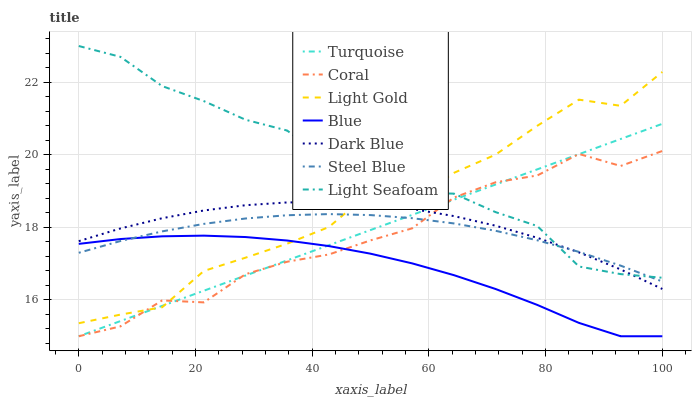Does Blue have the minimum area under the curve?
Answer yes or no. Yes. Does Light Seafoam have the maximum area under the curve?
Answer yes or no. Yes. Does Turquoise have the minimum area under the curve?
Answer yes or no. No. Does Turquoise have the maximum area under the curve?
Answer yes or no. No. Is Turquoise the smoothest?
Answer yes or no. Yes. Is Light Seafoam the roughest?
Answer yes or no. Yes. Is Coral the smoothest?
Answer yes or no. No. Is Coral the roughest?
Answer yes or no. No. Does Blue have the lowest value?
Answer yes or no. Yes. Does Steel Blue have the lowest value?
Answer yes or no. No. Does Light Seafoam have the highest value?
Answer yes or no. Yes. Does Turquoise have the highest value?
Answer yes or no. No. Is Blue less than Dark Blue?
Answer yes or no. Yes. Is Light Seafoam greater than Blue?
Answer yes or no. Yes. Does Steel Blue intersect Dark Blue?
Answer yes or no. Yes. Is Steel Blue less than Dark Blue?
Answer yes or no. No. Is Steel Blue greater than Dark Blue?
Answer yes or no. No. Does Blue intersect Dark Blue?
Answer yes or no. No. 